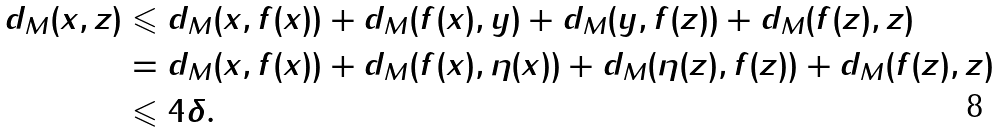Convert formula to latex. <formula><loc_0><loc_0><loc_500><loc_500>d _ { M } ( x , z ) & \leqslant d _ { M } ( x , f ( x ) ) + d _ { M } ( f ( x ) , y ) + d _ { M } ( y , f ( z ) ) + d _ { M } ( f ( z ) , z ) \\ & = d _ { M } ( x , f ( x ) ) + d _ { M } ( f ( x ) , \eta ( x ) ) + d _ { M } ( \eta ( z ) , f ( z ) ) + d _ { M } ( f ( z ) , z ) \\ & \leqslant 4 \delta .</formula> 